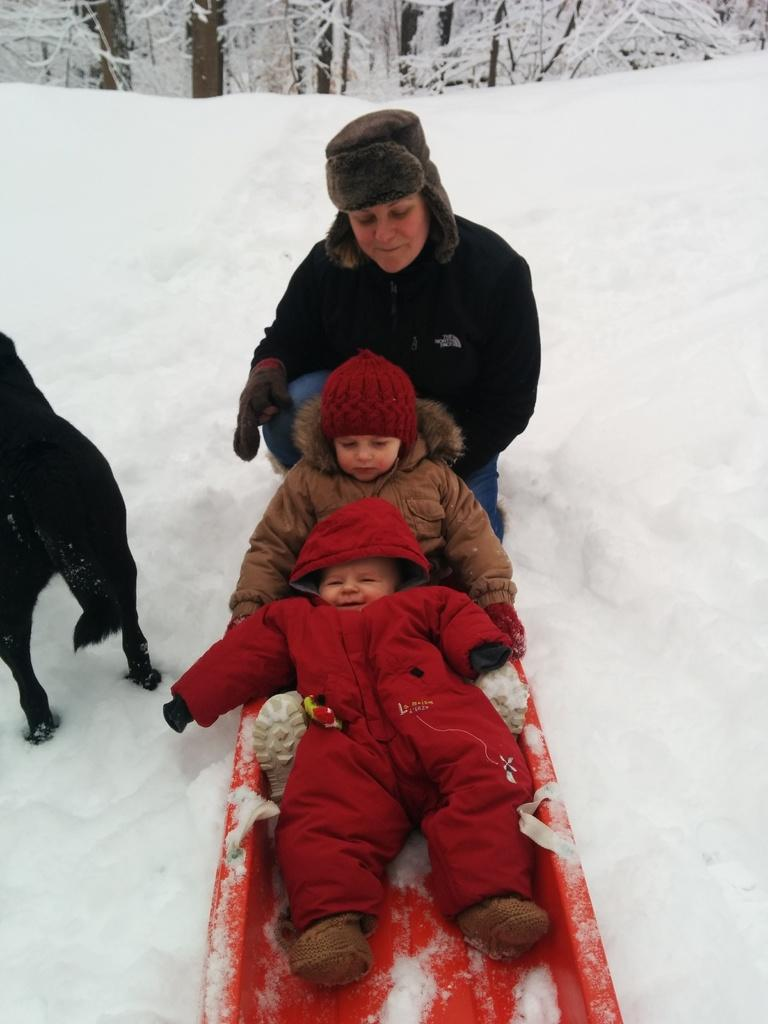How many people are sitting in the image? There are two persons sitting in the image. What is the position of the third person in the image? There is a person on their knee in the image. What animal is present in the image? There is a dog standing in the image. What type of vegetation can be seen in the background of the image? There are trees visible at the back of the image. What is the ground condition in the image? There is snow at the bottom of the image. What type of train can be seen passing by in the image? There is no train present in the image; it features two people sitting, a person on their knee, a dog standing, trees in the background, and snow on the ground. 